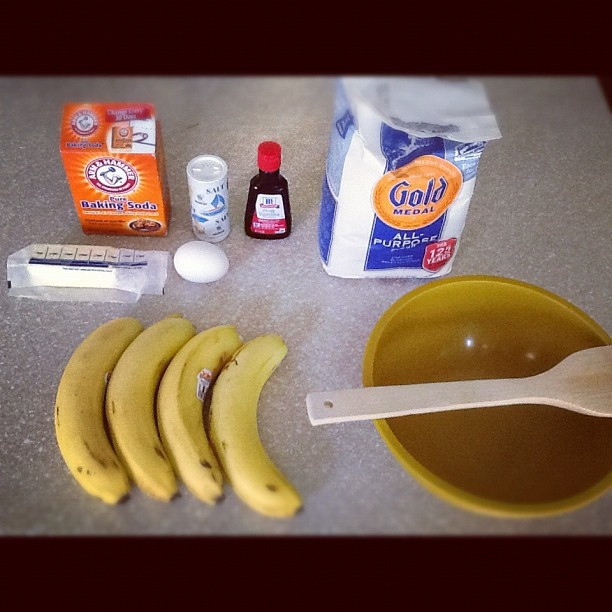Describe the objects in this image and their specific colors. I can see bowl in black, maroon, olive, and darkgray tones, spoon in black, darkgray, gray, and lightgray tones, banana in black, tan, olive, and khaki tones, banana in black, tan, and olive tones, and banana in black, tan, and olive tones in this image. 